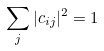Convert formula to latex. <formula><loc_0><loc_0><loc_500><loc_500>\sum _ { j } | c _ { i j } | ^ { 2 } = 1</formula> 